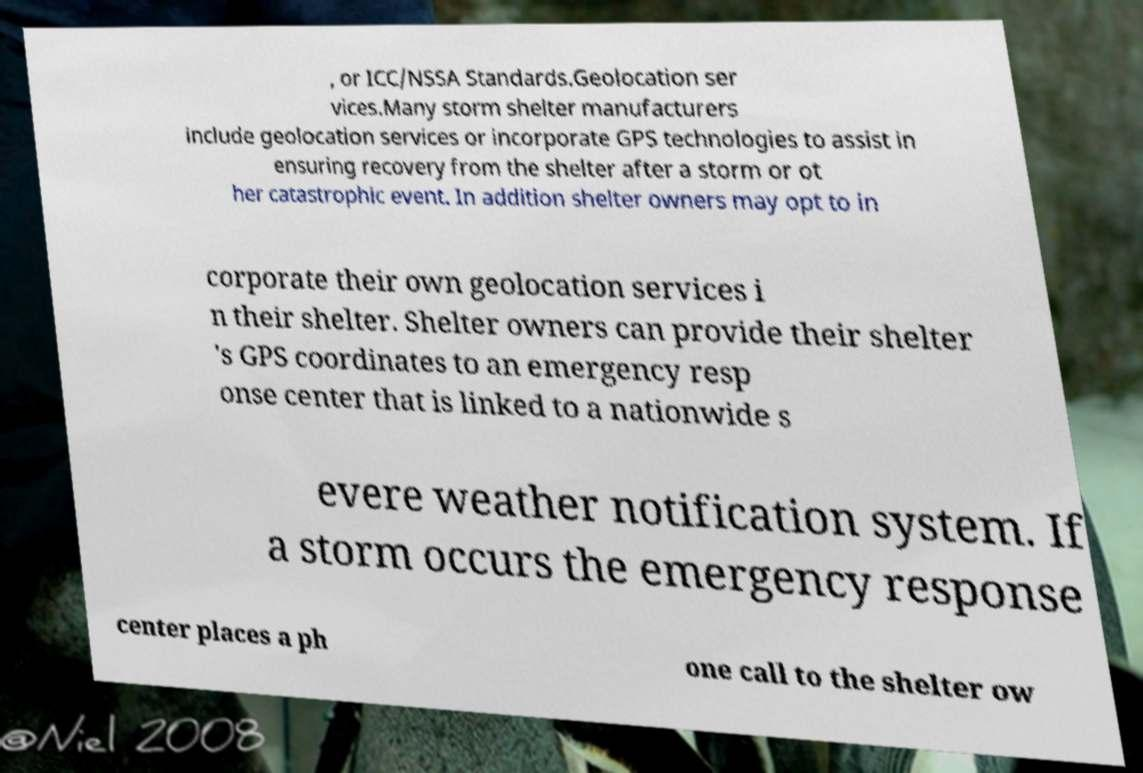Please read and relay the text visible in this image. What does it say? , or ICC/NSSA Standards.Geolocation ser vices.Many storm shelter manufacturers include geolocation services or incorporate GPS technologies to assist in ensuring recovery from the shelter after a storm or ot her catastrophic event. In addition shelter owners may opt to in corporate their own geolocation services i n their shelter. Shelter owners can provide their shelter 's GPS coordinates to an emergency resp onse center that is linked to a nationwide s evere weather notification system. If a storm occurs the emergency response center places a ph one call to the shelter ow 